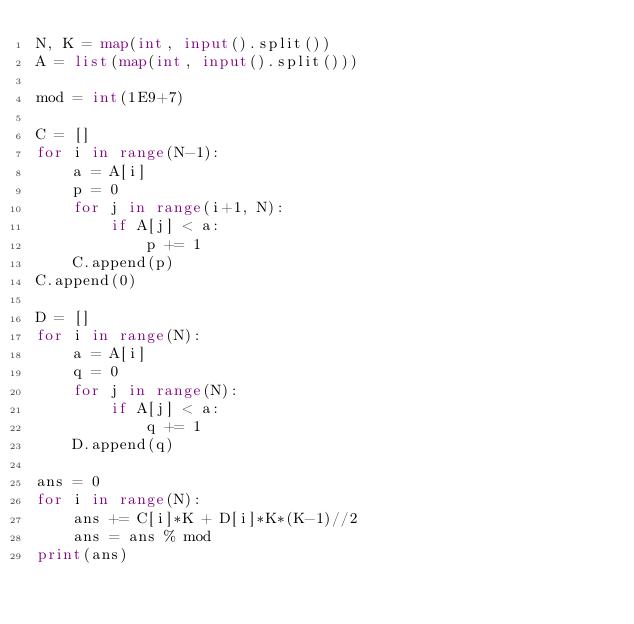<code> <loc_0><loc_0><loc_500><loc_500><_Python_>N, K = map(int, input().split())
A = list(map(int, input().split()))

mod = int(1E9+7)

C = []
for i in range(N-1):
    a = A[i]
    p = 0
    for j in range(i+1, N):
        if A[j] < a:
            p += 1
    C.append(p)
C.append(0)

D = []
for i in range(N):
    a = A[i]
    q = 0
    for j in range(N):
        if A[j] < a:
            q += 1
    D.append(q)

ans = 0
for i in range(N):
    ans += C[i]*K + D[i]*K*(K-1)//2
    ans = ans % mod
print(ans)</code> 